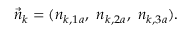Convert formula to latex. <formula><loc_0><loc_0><loc_500><loc_500>\vec { n } _ { k } = ( n _ { k , 1 a } , \ n _ { k , 2 a } , \ n _ { k , 3 a } ) .</formula> 